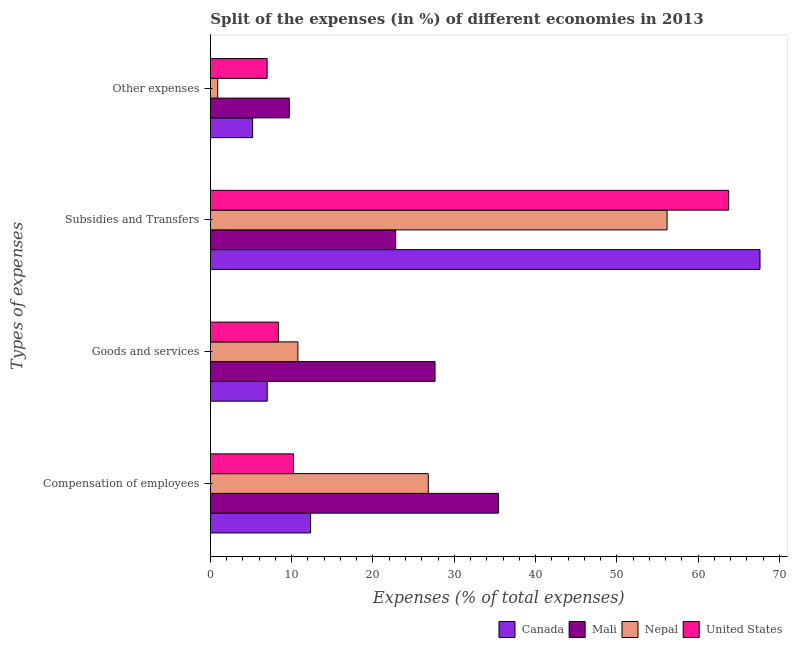How many different coloured bars are there?
Your answer should be very brief. 4. Are the number of bars per tick equal to the number of legend labels?
Give a very brief answer. Yes. Are the number of bars on each tick of the Y-axis equal?
Provide a short and direct response. Yes. How many bars are there on the 2nd tick from the top?
Your response must be concise. 4. What is the label of the 4th group of bars from the top?
Your answer should be compact. Compensation of employees. What is the percentage of amount spent on subsidies in United States?
Your answer should be compact. 63.75. Across all countries, what is the maximum percentage of amount spent on subsidies?
Make the answer very short. 67.61. Across all countries, what is the minimum percentage of amount spent on other expenses?
Offer a terse response. 0.9. In which country was the percentage of amount spent on compensation of employees minimum?
Offer a terse response. United States. What is the total percentage of amount spent on other expenses in the graph?
Ensure brevity in your answer.  22.78. What is the difference between the percentage of amount spent on compensation of employees in United States and that in Mali?
Provide a succinct answer. -25.19. What is the difference between the percentage of amount spent on other expenses in Nepal and the percentage of amount spent on compensation of employees in Mali?
Give a very brief answer. -34.52. What is the average percentage of amount spent on other expenses per country?
Offer a terse response. 5.7. What is the difference between the percentage of amount spent on subsidies and percentage of amount spent on compensation of employees in Canada?
Your response must be concise. 55.28. In how many countries, is the percentage of amount spent on subsidies greater than 32 %?
Your response must be concise. 3. What is the ratio of the percentage of amount spent on goods and services in Nepal to that in Canada?
Provide a succinct answer. 1.54. Is the difference between the percentage of amount spent on other expenses in United States and Nepal greater than the difference between the percentage of amount spent on subsidies in United States and Nepal?
Give a very brief answer. No. What is the difference between the highest and the second highest percentage of amount spent on compensation of employees?
Provide a short and direct response. 8.62. What is the difference between the highest and the lowest percentage of amount spent on compensation of employees?
Give a very brief answer. 25.19. In how many countries, is the percentage of amount spent on goods and services greater than the average percentage of amount spent on goods and services taken over all countries?
Give a very brief answer. 1. Is the sum of the percentage of amount spent on compensation of employees in Mali and Canada greater than the maximum percentage of amount spent on subsidies across all countries?
Provide a short and direct response. No. What does the 4th bar from the bottom in Goods and services represents?
Offer a very short reply. United States. How many bars are there?
Provide a succinct answer. 16. How many countries are there in the graph?
Give a very brief answer. 4. Where does the legend appear in the graph?
Offer a very short reply. Bottom right. How many legend labels are there?
Your response must be concise. 4. How are the legend labels stacked?
Offer a terse response. Horizontal. What is the title of the graph?
Provide a short and direct response. Split of the expenses (in %) of different economies in 2013. Does "Afghanistan" appear as one of the legend labels in the graph?
Your answer should be compact. No. What is the label or title of the X-axis?
Your response must be concise. Expenses (% of total expenses). What is the label or title of the Y-axis?
Ensure brevity in your answer.  Types of expenses. What is the Expenses (% of total expenses) in Canada in Compensation of employees?
Keep it short and to the point. 12.33. What is the Expenses (% of total expenses) of Mali in Compensation of employees?
Give a very brief answer. 35.42. What is the Expenses (% of total expenses) of Nepal in Compensation of employees?
Your response must be concise. 26.8. What is the Expenses (% of total expenses) in United States in Compensation of employees?
Your answer should be very brief. 10.23. What is the Expenses (% of total expenses) in Canada in Goods and services?
Provide a short and direct response. 6.99. What is the Expenses (% of total expenses) in Mali in Goods and services?
Your answer should be very brief. 27.63. What is the Expenses (% of total expenses) of Nepal in Goods and services?
Your response must be concise. 10.76. What is the Expenses (% of total expenses) of United States in Goods and services?
Offer a terse response. 8.37. What is the Expenses (% of total expenses) of Canada in Subsidies and Transfers?
Offer a very short reply. 67.61. What is the Expenses (% of total expenses) in Mali in Subsidies and Transfers?
Provide a short and direct response. 22.79. What is the Expenses (% of total expenses) of Nepal in Subsidies and Transfers?
Make the answer very short. 56.17. What is the Expenses (% of total expenses) of United States in Subsidies and Transfers?
Offer a very short reply. 63.75. What is the Expenses (% of total expenses) of Canada in Other expenses?
Provide a succinct answer. 5.2. What is the Expenses (% of total expenses) of Mali in Other expenses?
Offer a very short reply. 9.71. What is the Expenses (% of total expenses) in Nepal in Other expenses?
Provide a short and direct response. 0.9. What is the Expenses (% of total expenses) of United States in Other expenses?
Offer a terse response. 6.98. Across all Types of expenses, what is the maximum Expenses (% of total expenses) of Canada?
Make the answer very short. 67.61. Across all Types of expenses, what is the maximum Expenses (% of total expenses) in Mali?
Keep it short and to the point. 35.42. Across all Types of expenses, what is the maximum Expenses (% of total expenses) of Nepal?
Keep it short and to the point. 56.17. Across all Types of expenses, what is the maximum Expenses (% of total expenses) of United States?
Your answer should be compact. 63.75. Across all Types of expenses, what is the minimum Expenses (% of total expenses) of Canada?
Ensure brevity in your answer.  5.2. Across all Types of expenses, what is the minimum Expenses (% of total expenses) of Mali?
Provide a succinct answer. 9.71. Across all Types of expenses, what is the minimum Expenses (% of total expenses) in Nepal?
Your response must be concise. 0.9. Across all Types of expenses, what is the minimum Expenses (% of total expenses) in United States?
Your answer should be compact. 6.98. What is the total Expenses (% of total expenses) in Canada in the graph?
Offer a terse response. 92.12. What is the total Expenses (% of total expenses) in Mali in the graph?
Make the answer very short. 95.55. What is the total Expenses (% of total expenses) in Nepal in the graph?
Offer a very short reply. 94.65. What is the total Expenses (% of total expenses) of United States in the graph?
Ensure brevity in your answer.  89.33. What is the difference between the Expenses (% of total expenses) in Canada in Compensation of employees and that in Goods and services?
Keep it short and to the point. 5.34. What is the difference between the Expenses (% of total expenses) of Mali in Compensation of employees and that in Goods and services?
Your answer should be compact. 7.79. What is the difference between the Expenses (% of total expenses) in Nepal in Compensation of employees and that in Goods and services?
Provide a short and direct response. 16.04. What is the difference between the Expenses (% of total expenses) in United States in Compensation of employees and that in Goods and services?
Ensure brevity in your answer.  1.86. What is the difference between the Expenses (% of total expenses) of Canada in Compensation of employees and that in Subsidies and Transfers?
Provide a succinct answer. -55.28. What is the difference between the Expenses (% of total expenses) in Mali in Compensation of employees and that in Subsidies and Transfers?
Ensure brevity in your answer.  12.63. What is the difference between the Expenses (% of total expenses) in Nepal in Compensation of employees and that in Subsidies and Transfers?
Ensure brevity in your answer.  -29.37. What is the difference between the Expenses (% of total expenses) of United States in Compensation of employees and that in Subsidies and Transfers?
Your answer should be very brief. -53.52. What is the difference between the Expenses (% of total expenses) of Canada in Compensation of employees and that in Other expenses?
Offer a very short reply. 7.13. What is the difference between the Expenses (% of total expenses) of Mali in Compensation of employees and that in Other expenses?
Provide a short and direct response. 25.71. What is the difference between the Expenses (% of total expenses) of Nepal in Compensation of employees and that in Other expenses?
Provide a succinct answer. 25.9. What is the difference between the Expenses (% of total expenses) in United States in Compensation of employees and that in Other expenses?
Your answer should be very brief. 3.25. What is the difference between the Expenses (% of total expenses) in Canada in Goods and services and that in Subsidies and Transfers?
Offer a terse response. -60.61. What is the difference between the Expenses (% of total expenses) in Mali in Goods and services and that in Subsidies and Transfers?
Provide a succinct answer. 4.84. What is the difference between the Expenses (% of total expenses) of Nepal in Goods and services and that in Subsidies and Transfers?
Provide a succinct answer. -45.41. What is the difference between the Expenses (% of total expenses) of United States in Goods and services and that in Subsidies and Transfers?
Your answer should be compact. -55.38. What is the difference between the Expenses (% of total expenses) in Canada in Goods and services and that in Other expenses?
Ensure brevity in your answer.  1.8. What is the difference between the Expenses (% of total expenses) of Mali in Goods and services and that in Other expenses?
Give a very brief answer. 17.93. What is the difference between the Expenses (% of total expenses) in Nepal in Goods and services and that in Other expenses?
Provide a short and direct response. 9.86. What is the difference between the Expenses (% of total expenses) of United States in Goods and services and that in Other expenses?
Offer a terse response. 1.39. What is the difference between the Expenses (% of total expenses) in Canada in Subsidies and Transfers and that in Other expenses?
Make the answer very short. 62.41. What is the difference between the Expenses (% of total expenses) of Mali in Subsidies and Transfers and that in Other expenses?
Offer a terse response. 13.09. What is the difference between the Expenses (% of total expenses) of Nepal in Subsidies and Transfers and that in Other expenses?
Keep it short and to the point. 55.27. What is the difference between the Expenses (% of total expenses) in United States in Subsidies and Transfers and that in Other expenses?
Your response must be concise. 56.77. What is the difference between the Expenses (% of total expenses) in Canada in Compensation of employees and the Expenses (% of total expenses) in Mali in Goods and services?
Keep it short and to the point. -15.31. What is the difference between the Expenses (% of total expenses) in Canada in Compensation of employees and the Expenses (% of total expenses) in Nepal in Goods and services?
Keep it short and to the point. 1.56. What is the difference between the Expenses (% of total expenses) in Canada in Compensation of employees and the Expenses (% of total expenses) in United States in Goods and services?
Offer a very short reply. 3.96. What is the difference between the Expenses (% of total expenses) of Mali in Compensation of employees and the Expenses (% of total expenses) of Nepal in Goods and services?
Your answer should be compact. 24.66. What is the difference between the Expenses (% of total expenses) of Mali in Compensation of employees and the Expenses (% of total expenses) of United States in Goods and services?
Your response must be concise. 27.05. What is the difference between the Expenses (% of total expenses) of Nepal in Compensation of employees and the Expenses (% of total expenses) of United States in Goods and services?
Give a very brief answer. 18.43. What is the difference between the Expenses (% of total expenses) in Canada in Compensation of employees and the Expenses (% of total expenses) in Mali in Subsidies and Transfers?
Keep it short and to the point. -10.46. What is the difference between the Expenses (% of total expenses) in Canada in Compensation of employees and the Expenses (% of total expenses) in Nepal in Subsidies and Transfers?
Your answer should be very brief. -43.85. What is the difference between the Expenses (% of total expenses) in Canada in Compensation of employees and the Expenses (% of total expenses) in United States in Subsidies and Transfers?
Ensure brevity in your answer.  -51.42. What is the difference between the Expenses (% of total expenses) in Mali in Compensation of employees and the Expenses (% of total expenses) in Nepal in Subsidies and Transfers?
Provide a short and direct response. -20.75. What is the difference between the Expenses (% of total expenses) of Mali in Compensation of employees and the Expenses (% of total expenses) of United States in Subsidies and Transfers?
Offer a terse response. -28.33. What is the difference between the Expenses (% of total expenses) of Nepal in Compensation of employees and the Expenses (% of total expenses) of United States in Subsidies and Transfers?
Offer a terse response. -36.95. What is the difference between the Expenses (% of total expenses) of Canada in Compensation of employees and the Expenses (% of total expenses) of Mali in Other expenses?
Give a very brief answer. 2.62. What is the difference between the Expenses (% of total expenses) in Canada in Compensation of employees and the Expenses (% of total expenses) in Nepal in Other expenses?
Provide a succinct answer. 11.42. What is the difference between the Expenses (% of total expenses) of Canada in Compensation of employees and the Expenses (% of total expenses) of United States in Other expenses?
Keep it short and to the point. 5.35. What is the difference between the Expenses (% of total expenses) in Mali in Compensation of employees and the Expenses (% of total expenses) in Nepal in Other expenses?
Ensure brevity in your answer.  34.52. What is the difference between the Expenses (% of total expenses) in Mali in Compensation of employees and the Expenses (% of total expenses) in United States in Other expenses?
Make the answer very short. 28.44. What is the difference between the Expenses (% of total expenses) in Nepal in Compensation of employees and the Expenses (% of total expenses) in United States in Other expenses?
Provide a succinct answer. 19.83. What is the difference between the Expenses (% of total expenses) in Canada in Goods and services and the Expenses (% of total expenses) in Mali in Subsidies and Transfers?
Your answer should be very brief. -15.8. What is the difference between the Expenses (% of total expenses) in Canada in Goods and services and the Expenses (% of total expenses) in Nepal in Subsidies and Transfers?
Keep it short and to the point. -49.18. What is the difference between the Expenses (% of total expenses) in Canada in Goods and services and the Expenses (% of total expenses) in United States in Subsidies and Transfers?
Provide a succinct answer. -56.76. What is the difference between the Expenses (% of total expenses) in Mali in Goods and services and the Expenses (% of total expenses) in Nepal in Subsidies and Transfers?
Your answer should be very brief. -28.54. What is the difference between the Expenses (% of total expenses) of Mali in Goods and services and the Expenses (% of total expenses) of United States in Subsidies and Transfers?
Offer a terse response. -36.12. What is the difference between the Expenses (% of total expenses) in Nepal in Goods and services and the Expenses (% of total expenses) in United States in Subsidies and Transfers?
Your response must be concise. -52.99. What is the difference between the Expenses (% of total expenses) of Canada in Goods and services and the Expenses (% of total expenses) of Mali in Other expenses?
Keep it short and to the point. -2.71. What is the difference between the Expenses (% of total expenses) in Canada in Goods and services and the Expenses (% of total expenses) in Nepal in Other expenses?
Keep it short and to the point. 6.09. What is the difference between the Expenses (% of total expenses) of Canada in Goods and services and the Expenses (% of total expenses) of United States in Other expenses?
Offer a terse response. 0.01. What is the difference between the Expenses (% of total expenses) of Mali in Goods and services and the Expenses (% of total expenses) of Nepal in Other expenses?
Your answer should be very brief. 26.73. What is the difference between the Expenses (% of total expenses) in Mali in Goods and services and the Expenses (% of total expenses) in United States in Other expenses?
Your answer should be very brief. 20.66. What is the difference between the Expenses (% of total expenses) in Nepal in Goods and services and the Expenses (% of total expenses) in United States in Other expenses?
Your answer should be compact. 3.79. What is the difference between the Expenses (% of total expenses) in Canada in Subsidies and Transfers and the Expenses (% of total expenses) in Mali in Other expenses?
Offer a very short reply. 57.9. What is the difference between the Expenses (% of total expenses) in Canada in Subsidies and Transfers and the Expenses (% of total expenses) in Nepal in Other expenses?
Offer a terse response. 66.7. What is the difference between the Expenses (% of total expenses) of Canada in Subsidies and Transfers and the Expenses (% of total expenses) of United States in Other expenses?
Your answer should be compact. 60.63. What is the difference between the Expenses (% of total expenses) in Mali in Subsidies and Transfers and the Expenses (% of total expenses) in Nepal in Other expenses?
Offer a very short reply. 21.89. What is the difference between the Expenses (% of total expenses) of Mali in Subsidies and Transfers and the Expenses (% of total expenses) of United States in Other expenses?
Make the answer very short. 15.82. What is the difference between the Expenses (% of total expenses) in Nepal in Subsidies and Transfers and the Expenses (% of total expenses) in United States in Other expenses?
Give a very brief answer. 49.2. What is the average Expenses (% of total expenses) in Canada per Types of expenses?
Offer a very short reply. 23.03. What is the average Expenses (% of total expenses) of Mali per Types of expenses?
Give a very brief answer. 23.89. What is the average Expenses (% of total expenses) in Nepal per Types of expenses?
Provide a short and direct response. 23.66. What is the average Expenses (% of total expenses) of United States per Types of expenses?
Offer a terse response. 22.33. What is the difference between the Expenses (% of total expenses) of Canada and Expenses (% of total expenses) of Mali in Compensation of employees?
Ensure brevity in your answer.  -23.09. What is the difference between the Expenses (% of total expenses) of Canada and Expenses (% of total expenses) of Nepal in Compensation of employees?
Make the answer very short. -14.48. What is the difference between the Expenses (% of total expenses) of Canada and Expenses (% of total expenses) of United States in Compensation of employees?
Your response must be concise. 2.1. What is the difference between the Expenses (% of total expenses) of Mali and Expenses (% of total expenses) of Nepal in Compensation of employees?
Your answer should be compact. 8.62. What is the difference between the Expenses (% of total expenses) in Mali and Expenses (% of total expenses) in United States in Compensation of employees?
Provide a short and direct response. 25.19. What is the difference between the Expenses (% of total expenses) in Nepal and Expenses (% of total expenses) in United States in Compensation of employees?
Provide a succinct answer. 16.58. What is the difference between the Expenses (% of total expenses) in Canada and Expenses (% of total expenses) in Mali in Goods and services?
Provide a succinct answer. -20.64. What is the difference between the Expenses (% of total expenses) in Canada and Expenses (% of total expenses) in Nepal in Goods and services?
Your response must be concise. -3.77. What is the difference between the Expenses (% of total expenses) in Canada and Expenses (% of total expenses) in United States in Goods and services?
Keep it short and to the point. -1.38. What is the difference between the Expenses (% of total expenses) in Mali and Expenses (% of total expenses) in Nepal in Goods and services?
Keep it short and to the point. 16.87. What is the difference between the Expenses (% of total expenses) of Mali and Expenses (% of total expenses) of United States in Goods and services?
Keep it short and to the point. 19.26. What is the difference between the Expenses (% of total expenses) of Nepal and Expenses (% of total expenses) of United States in Goods and services?
Provide a short and direct response. 2.39. What is the difference between the Expenses (% of total expenses) in Canada and Expenses (% of total expenses) in Mali in Subsidies and Transfers?
Make the answer very short. 44.81. What is the difference between the Expenses (% of total expenses) of Canada and Expenses (% of total expenses) of Nepal in Subsidies and Transfers?
Give a very brief answer. 11.43. What is the difference between the Expenses (% of total expenses) of Canada and Expenses (% of total expenses) of United States in Subsidies and Transfers?
Your answer should be compact. 3.85. What is the difference between the Expenses (% of total expenses) of Mali and Expenses (% of total expenses) of Nepal in Subsidies and Transfers?
Make the answer very short. -33.38. What is the difference between the Expenses (% of total expenses) in Mali and Expenses (% of total expenses) in United States in Subsidies and Transfers?
Your answer should be compact. -40.96. What is the difference between the Expenses (% of total expenses) of Nepal and Expenses (% of total expenses) of United States in Subsidies and Transfers?
Offer a terse response. -7.58. What is the difference between the Expenses (% of total expenses) of Canada and Expenses (% of total expenses) of Mali in Other expenses?
Provide a succinct answer. -4.51. What is the difference between the Expenses (% of total expenses) in Canada and Expenses (% of total expenses) in Nepal in Other expenses?
Provide a succinct answer. 4.29. What is the difference between the Expenses (% of total expenses) in Canada and Expenses (% of total expenses) in United States in Other expenses?
Your answer should be compact. -1.78. What is the difference between the Expenses (% of total expenses) of Mali and Expenses (% of total expenses) of Nepal in Other expenses?
Your response must be concise. 8.8. What is the difference between the Expenses (% of total expenses) of Mali and Expenses (% of total expenses) of United States in Other expenses?
Your answer should be compact. 2.73. What is the difference between the Expenses (% of total expenses) of Nepal and Expenses (% of total expenses) of United States in Other expenses?
Your response must be concise. -6.07. What is the ratio of the Expenses (% of total expenses) of Canada in Compensation of employees to that in Goods and services?
Provide a short and direct response. 1.76. What is the ratio of the Expenses (% of total expenses) of Mali in Compensation of employees to that in Goods and services?
Provide a short and direct response. 1.28. What is the ratio of the Expenses (% of total expenses) of Nepal in Compensation of employees to that in Goods and services?
Give a very brief answer. 2.49. What is the ratio of the Expenses (% of total expenses) in United States in Compensation of employees to that in Goods and services?
Offer a terse response. 1.22. What is the ratio of the Expenses (% of total expenses) in Canada in Compensation of employees to that in Subsidies and Transfers?
Your answer should be very brief. 0.18. What is the ratio of the Expenses (% of total expenses) in Mali in Compensation of employees to that in Subsidies and Transfers?
Keep it short and to the point. 1.55. What is the ratio of the Expenses (% of total expenses) in Nepal in Compensation of employees to that in Subsidies and Transfers?
Keep it short and to the point. 0.48. What is the ratio of the Expenses (% of total expenses) of United States in Compensation of employees to that in Subsidies and Transfers?
Provide a short and direct response. 0.16. What is the ratio of the Expenses (% of total expenses) of Canada in Compensation of employees to that in Other expenses?
Ensure brevity in your answer.  2.37. What is the ratio of the Expenses (% of total expenses) in Mali in Compensation of employees to that in Other expenses?
Keep it short and to the point. 3.65. What is the ratio of the Expenses (% of total expenses) in Nepal in Compensation of employees to that in Other expenses?
Your answer should be very brief. 29.63. What is the ratio of the Expenses (% of total expenses) in United States in Compensation of employees to that in Other expenses?
Keep it short and to the point. 1.47. What is the ratio of the Expenses (% of total expenses) in Canada in Goods and services to that in Subsidies and Transfers?
Make the answer very short. 0.1. What is the ratio of the Expenses (% of total expenses) of Mali in Goods and services to that in Subsidies and Transfers?
Give a very brief answer. 1.21. What is the ratio of the Expenses (% of total expenses) of Nepal in Goods and services to that in Subsidies and Transfers?
Offer a very short reply. 0.19. What is the ratio of the Expenses (% of total expenses) in United States in Goods and services to that in Subsidies and Transfers?
Ensure brevity in your answer.  0.13. What is the ratio of the Expenses (% of total expenses) in Canada in Goods and services to that in Other expenses?
Keep it short and to the point. 1.35. What is the ratio of the Expenses (% of total expenses) in Mali in Goods and services to that in Other expenses?
Your answer should be compact. 2.85. What is the ratio of the Expenses (% of total expenses) in Nepal in Goods and services to that in Other expenses?
Provide a succinct answer. 11.9. What is the ratio of the Expenses (% of total expenses) of United States in Goods and services to that in Other expenses?
Offer a very short reply. 1.2. What is the ratio of the Expenses (% of total expenses) in Canada in Subsidies and Transfers to that in Other expenses?
Offer a very short reply. 13.01. What is the ratio of the Expenses (% of total expenses) of Mali in Subsidies and Transfers to that in Other expenses?
Your answer should be compact. 2.35. What is the ratio of the Expenses (% of total expenses) of Nepal in Subsidies and Transfers to that in Other expenses?
Provide a succinct answer. 62.09. What is the ratio of the Expenses (% of total expenses) in United States in Subsidies and Transfers to that in Other expenses?
Provide a succinct answer. 9.14. What is the difference between the highest and the second highest Expenses (% of total expenses) in Canada?
Your response must be concise. 55.28. What is the difference between the highest and the second highest Expenses (% of total expenses) of Mali?
Your response must be concise. 7.79. What is the difference between the highest and the second highest Expenses (% of total expenses) of Nepal?
Provide a succinct answer. 29.37. What is the difference between the highest and the second highest Expenses (% of total expenses) of United States?
Your response must be concise. 53.52. What is the difference between the highest and the lowest Expenses (% of total expenses) of Canada?
Offer a terse response. 62.41. What is the difference between the highest and the lowest Expenses (% of total expenses) in Mali?
Offer a terse response. 25.71. What is the difference between the highest and the lowest Expenses (% of total expenses) in Nepal?
Offer a terse response. 55.27. What is the difference between the highest and the lowest Expenses (% of total expenses) of United States?
Keep it short and to the point. 56.77. 